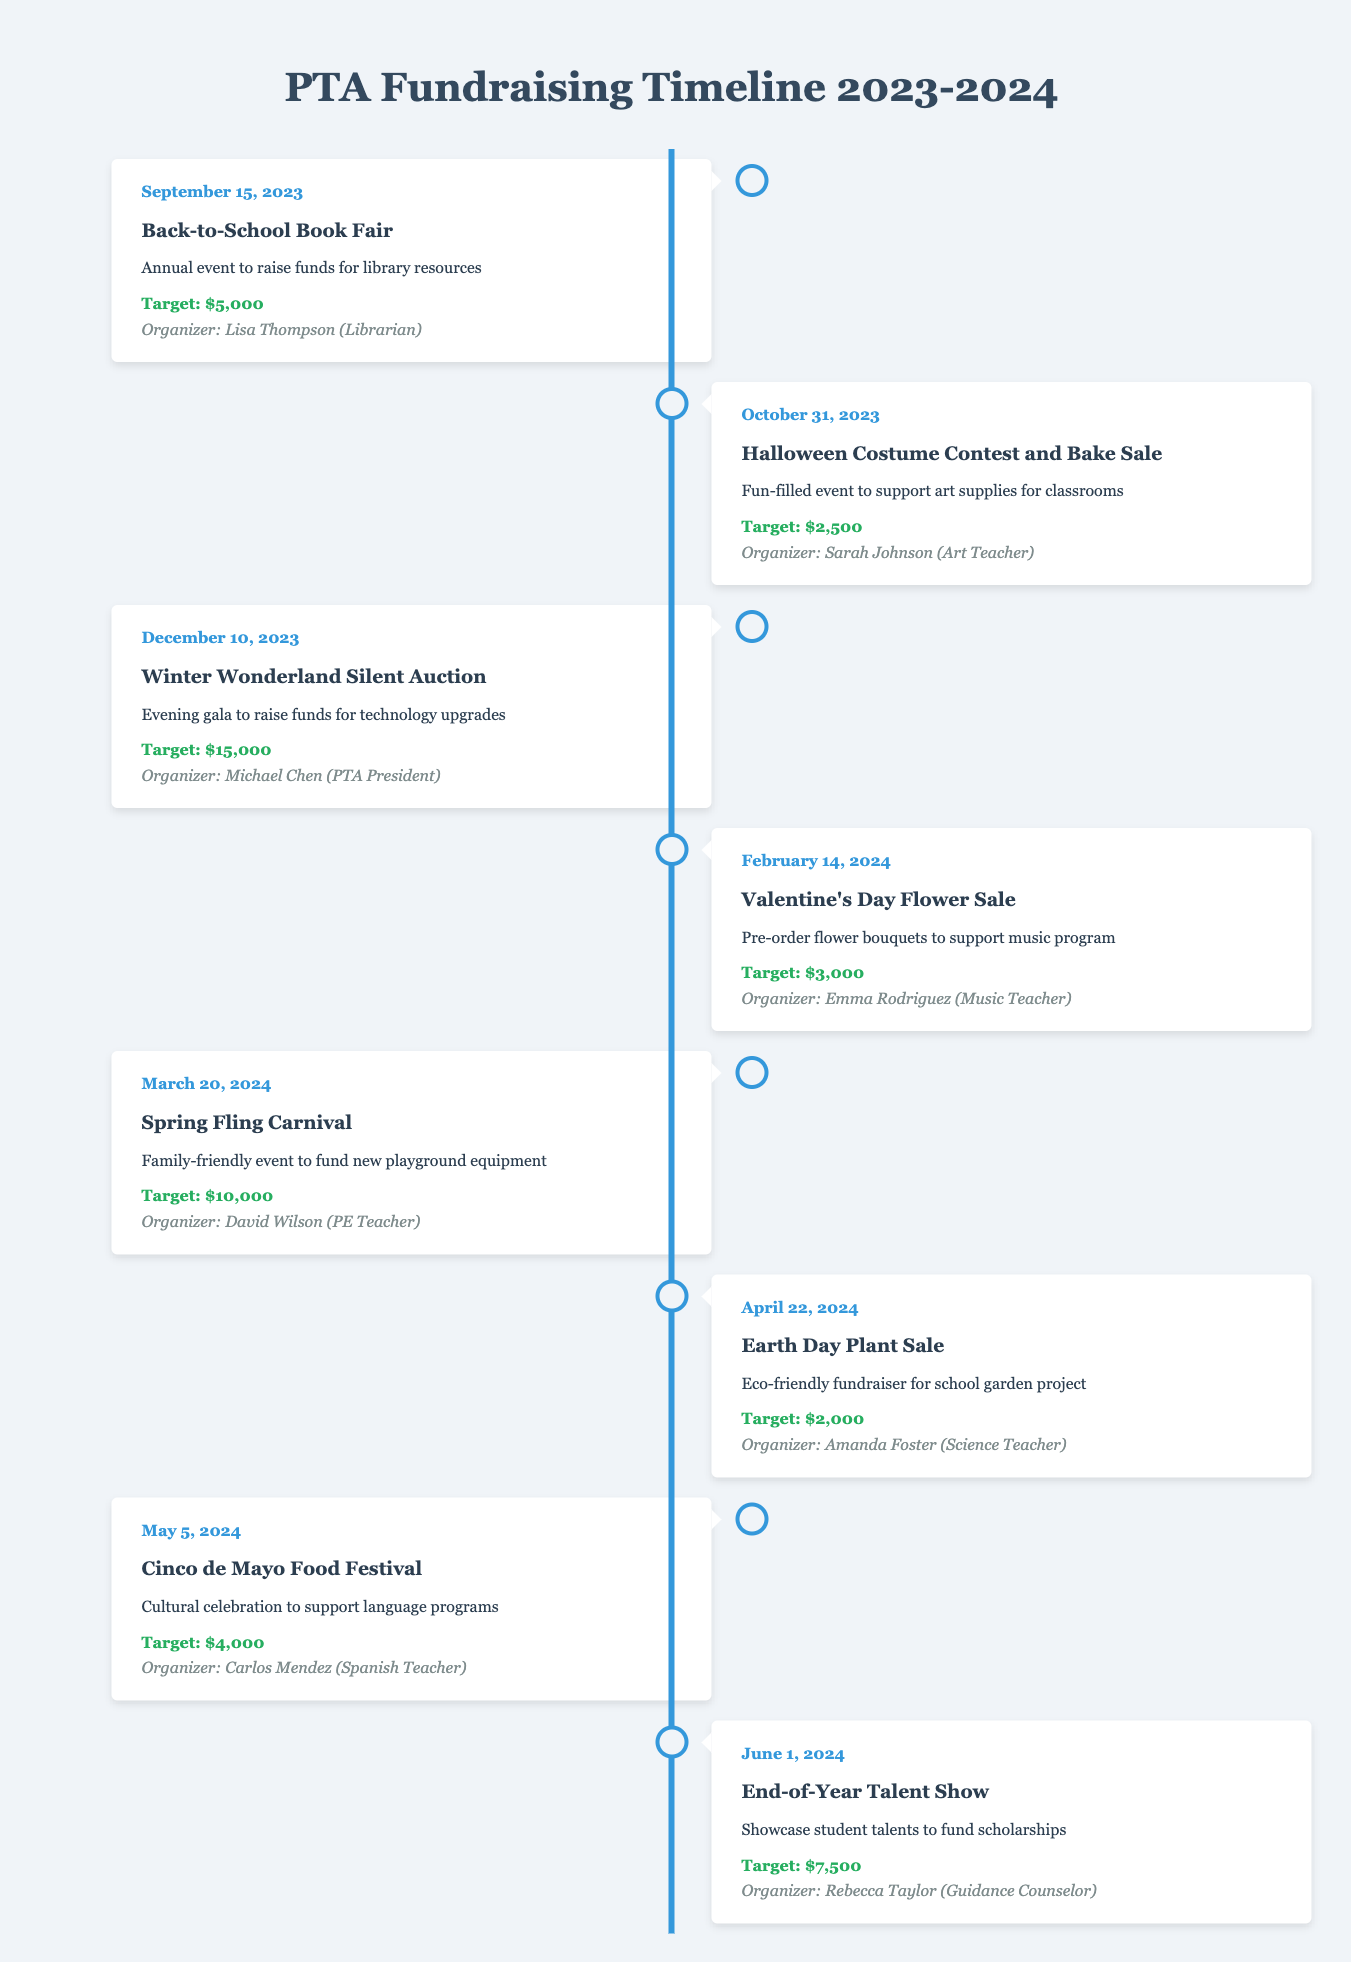What is the target amount for the Winter Wonderland Silent Auction? The table lists the event "Winter Wonderland Silent Auction" with a target amount provided directly in the corresponding row. The target is stated as "$15,000."
Answer: $15,000 Who is the organizer of the Cinco de Mayo Food Festival? Looking at the row for the "Cinco de Mayo Food Festival," the organizer is stated as "Carlos Mendez (Spanish Teacher)."
Answer: Carlos Mendez (Spanish Teacher) How much funding do the Valentine's Day Flower Sale and Earth Day Plant Sale aim to raise combined? The target for the Valentine's Day Flower Sale is "$3,000," and the Earth Day Plant Sale is "$2,000." Adding these amounts together gives 3,000 + 2,000 = 5,000.
Answer: $5,000 Did the PTA organize a fundraising event in December? Reviewing the table, there is an event scheduled for December 10, 2023, which is the "Winter Wonderland Silent Auction." This confirms that there is indeed an event in December.
Answer: Yes Which event has the highest fundraising target and who is organizing it? The table shows that the event with the highest target is the "Winter Wonderland Silent Auction" with a target of "$15,000." The organizer is "Michael Chen (PTA President)."
Answer: Winter Wonderland Silent Auction, Michael Chen (PTA President) What is the overall target amount for all events listed? The targets from each event are as follows: $5,000, $2,500, $15,000, $3,000, $10,000, $2,000, $4,000, and $7,500. Adding these amounts yields: 5,000 + 2,500 + 15,000 + 3,000 + 10,000 + 2,000 + 4,000 + 7,500 = 49,000.
Answer: $49,000 Is the goal for the Spring Fling Carnival greater than the combined targets of the Back-to-School Book Fair and Halloween Costume Contest? The target for the Spring Fling Carnival is "$10,000." The combined targets for the Back-to-School Book Fair ($5,000) and Halloween Costume Contest ($2,500) total $7,500. Since 10,000 is greater than 7,500, the statement is true.
Answer: Yes On which date is the Earth Day Plant Sale scheduled? The table specifies that the Earth Day Plant Sale is set for April 22, 2024. This information can be directly found in the respective row.
Answer: April 22, 2024 